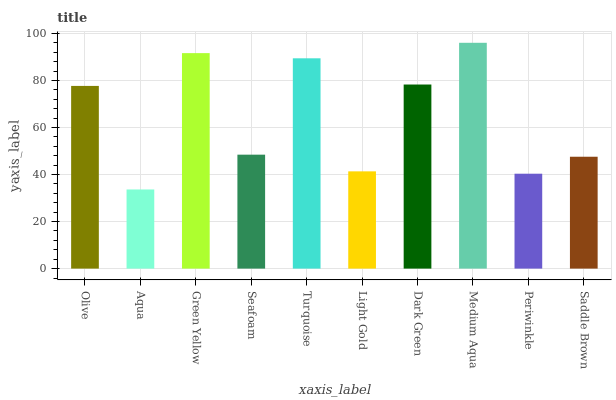Is Aqua the minimum?
Answer yes or no. Yes. Is Medium Aqua the maximum?
Answer yes or no. Yes. Is Green Yellow the minimum?
Answer yes or no. No. Is Green Yellow the maximum?
Answer yes or no. No. Is Green Yellow greater than Aqua?
Answer yes or no. Yes. Is Aqua less than Green Yellow?
Answer yes or no. Yes. Is Aqua greater than Green Yellow?
Answer yes or no. No. Is Green Yellow less than Aqua?
Answer yes or no. No. Is Olive the high median?
Answer yes or no. Yes. Is Seafoam the low median?
Answer yes or no. Yes. Is Green Yellow the high median?
Answer yes or no. No. Is Dark Green the low median?
Answer yes or no. No. 